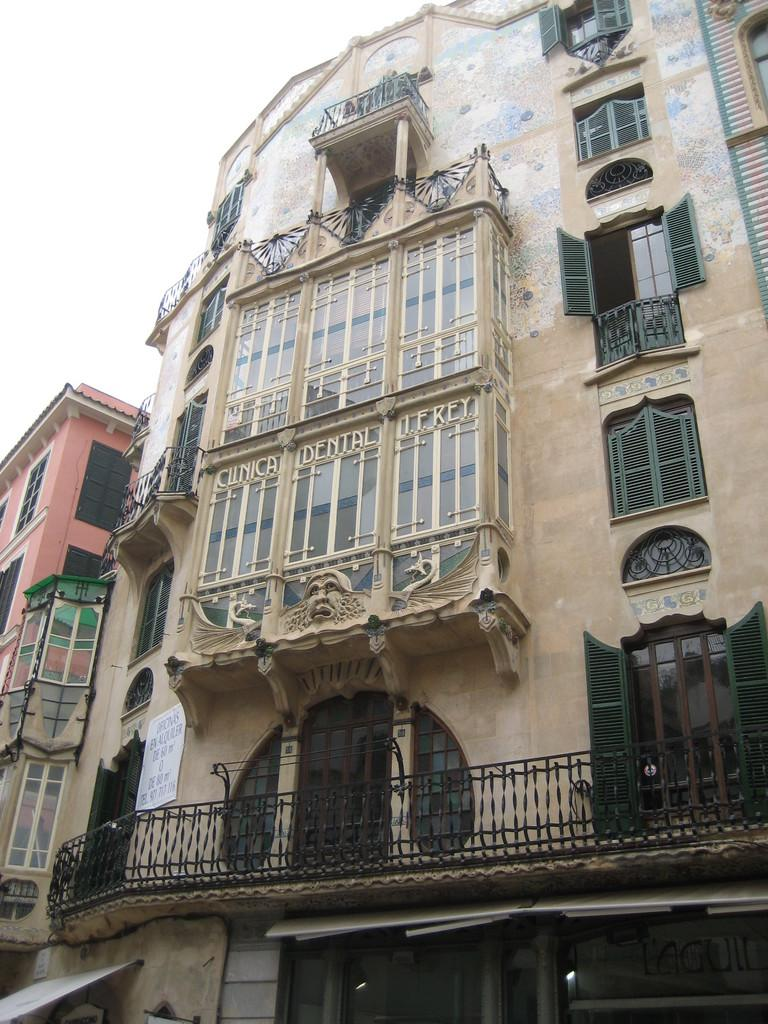How many buildings can be seen in the image? There are two buildings in the image. What is written on the windows of the first building? There is a dental name on the windows of the first building. What type of pie is being served by the laborer in the image? There is no laborer or pie present in the image. What level of difficulty is the building project in the image? There is no building project or level of difficulty mentioned in the image. 